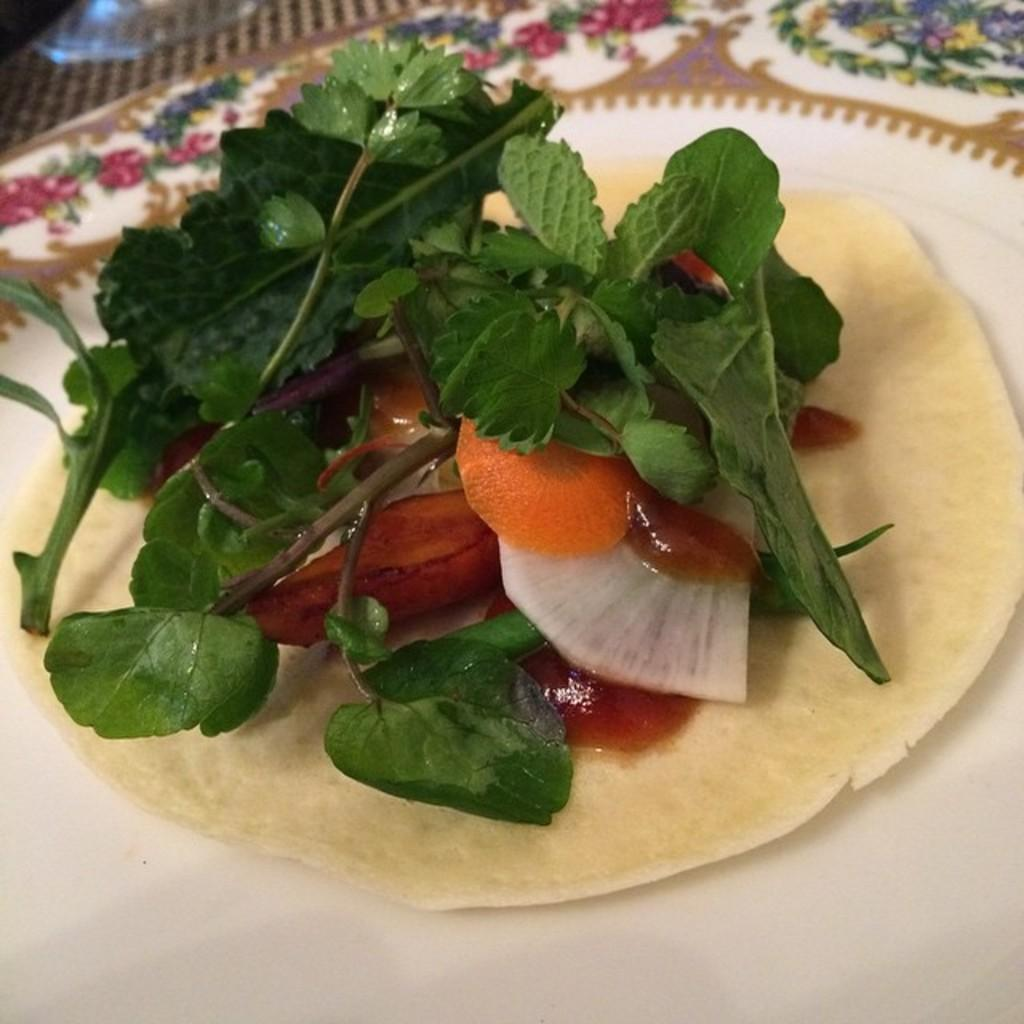What type of food is visible in the image? There are leafy vegetables and other vegetables in the image. How are the vegetables arranged in the image? The vegetables are on a plate in the image. Where is the plate with vegetables located? The plate with vegetables is on a table in the image. Can you see a river flowing in the background of the image? There is no river visible in the image; it features vegetables on a plate. 